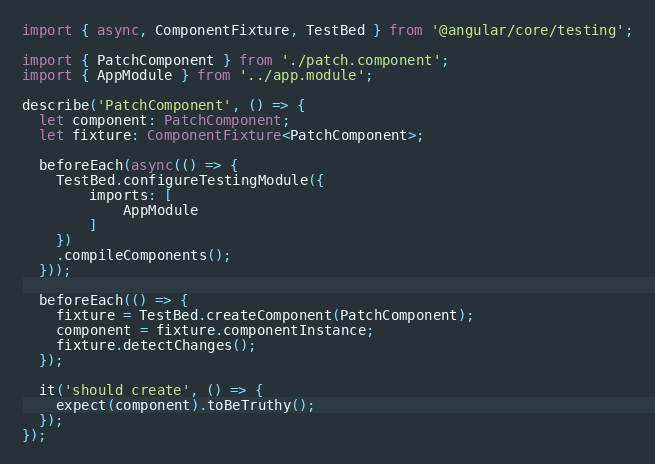Convert code to text. <code><loc_0><loc_0><loc_500><loc_500><_TypeScript_>import { async, ComponentFixture, TestBed } from '@angular/core/testing';

import { PatchComponent } from './patch.component';
import { AppModule } from '../app.module';

describe('PatchComponent', () => {
  let component: PatchComponent;
  let fixture: ComponentFixture<PatchComponent>;

  beforeEach(async(() => {
    TestBed.configureTestingModule({
        imports: [
            AppModule
        ]
    })
    .compileComponents();
  }));

  beforeEach(() => {
    fixture = TestBed.createComponent(PatchComponent);
    component = fixture.componentInstance;
    fixture.detectChanges();
  });

  it('should create', () => {
    expect(component).toBeTruthy();
  });
});
</code> 